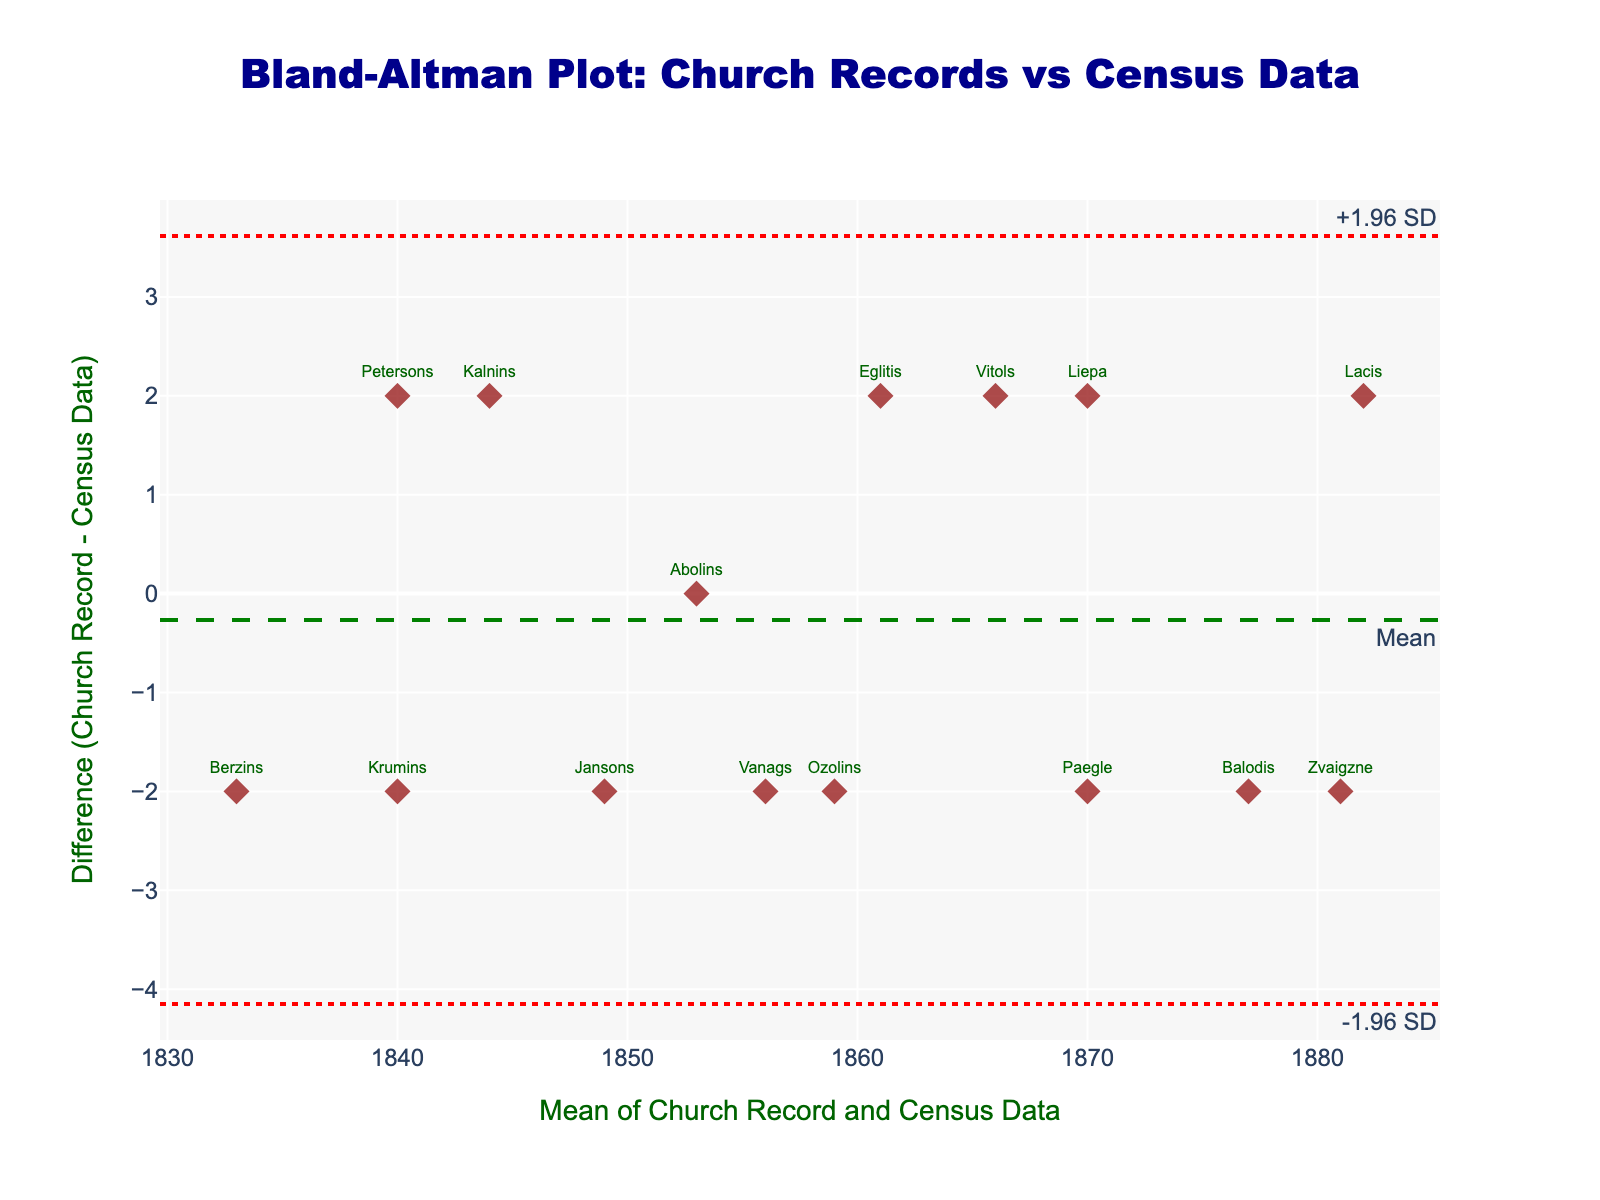What is the title of the plot? The title of the plot is the header text that provides a brief description of what the plot represents. It is located at the top of the figure.
Answer: Bland-Altman Plot: Church Records vs Census Data How many families are represented in the plot? Count the number of markers (points) on the Bland-Altman plot, as each marker represents one family.
Answer: 15 What do the axes of the plot represent? The x-axis represents the mean of the church record and census data for each family, while the y-axis represents the difference between these two data points (church record minus census data).
Answer: Mean (x-axis) and Difference (y-axis) What color are the data points and what is their shape? Observe the visual characteristics of the data points in the plot, including their color and shape.
Answer: Dark red and diamond-shaped What does the green dashed line represent? The green dashed line is the mean difference line, and the plot includes a label for it ('Mean'). It represents the average of all differences between church record and census data.
Answer: Mean difference What are the positions (values) of the red dotted lines? The positions of the red dotted lines represent the limits of agreement (mean difference ± 1.96 times the standard deviation of the differences).
Answer: Values of +1.96 SD and -1.96 SD Which family has the largest positive difference between church record and census data? Identify the data point that has the highest position on the y-axis, which corresponds to the largest positive difference.
Answer: Berzins Which family has the largest negative difference between church record and census data? Identify the data point that has the lowest position on the y-axis, which corresponds to the largest negative difference.
Answer: Lacis How many families have a difference close to zero? Look for data points that are positioned close to the y-axis value of zero, indicating minimal difference between church record and census data. Note the number of such points.
Answer: 1 (Abolins) Are there any families with matching church record and census data? Look for any data point on the y-axis at the value zero, indicating that the difference between church record and census data is zero.
Answer: Yes, Abolins 